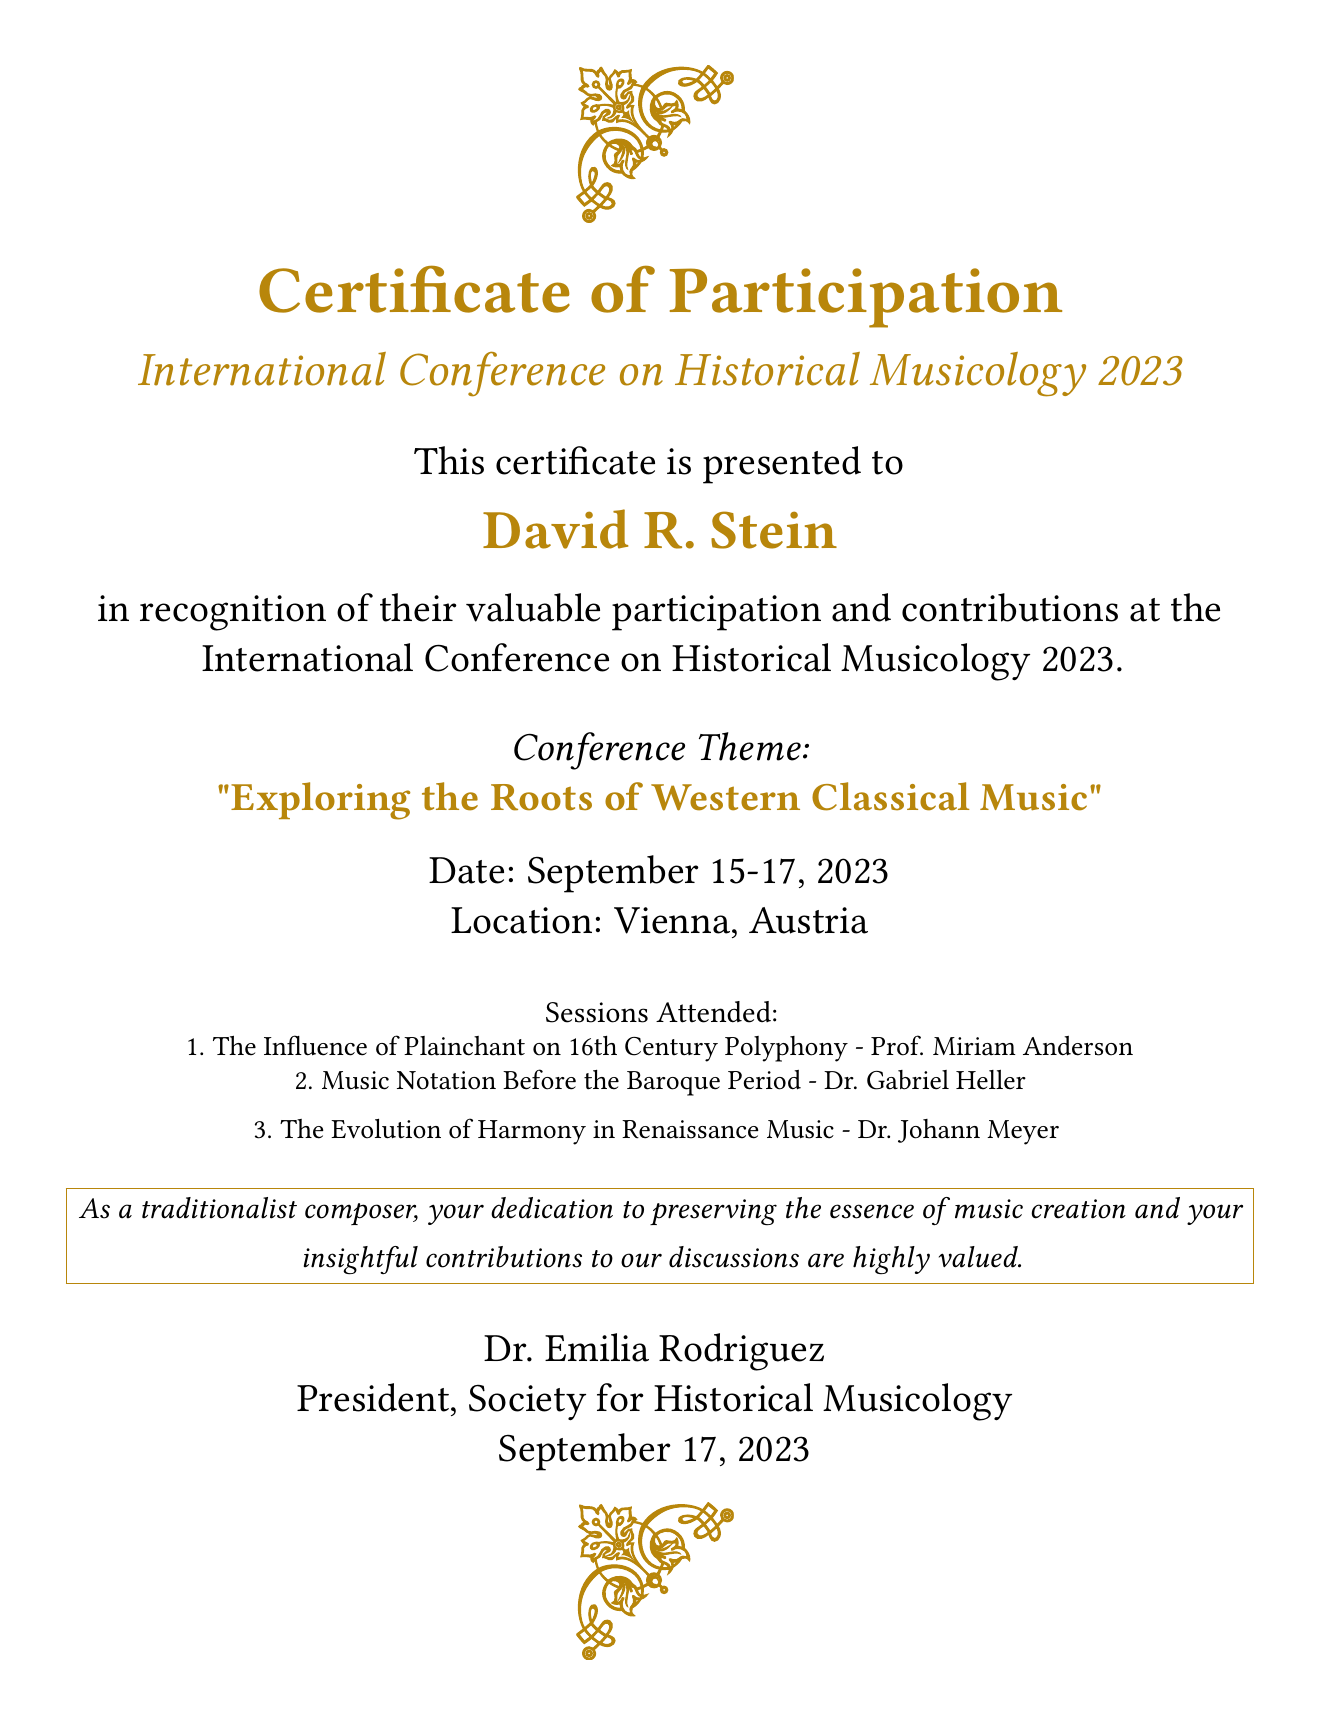What is the title of the certificate? The title of the certificate is presented near the top of the document.
Answer: Certificate of Participation Who is the recipient of the certificate? The recipient's name is prominently displayed in the document.
Answer: David R. Stein What is the theme of the conference? The conference theme is mentioned in bold, making it easily identifiable.
Answer: Exploring the Roots of Western Classical Music When was the conference held? The date is explicitly stated in the document related to the event.
Answer: September 15-17, 2023 Where was the conference located? The location of the conference is clearly specified in the document.
Answer: Vienna, Austria Who signed the certificate? The certificate includes a name at the bottom, indicating the signatory.
Answer: Dr. Emilia Rodriguez What position does the signatory hold? The document outlines the role of the individual who signed the certificate.
Answer: President, Society for Historical Musicology How many sessions did David R. Stein attend? The number of sessions is indicated through a list in the document.
Answer: 3 What is the focus of the attended sessions? The theme of the sessions gives insight into their content.
Answer: Historical Musicology 